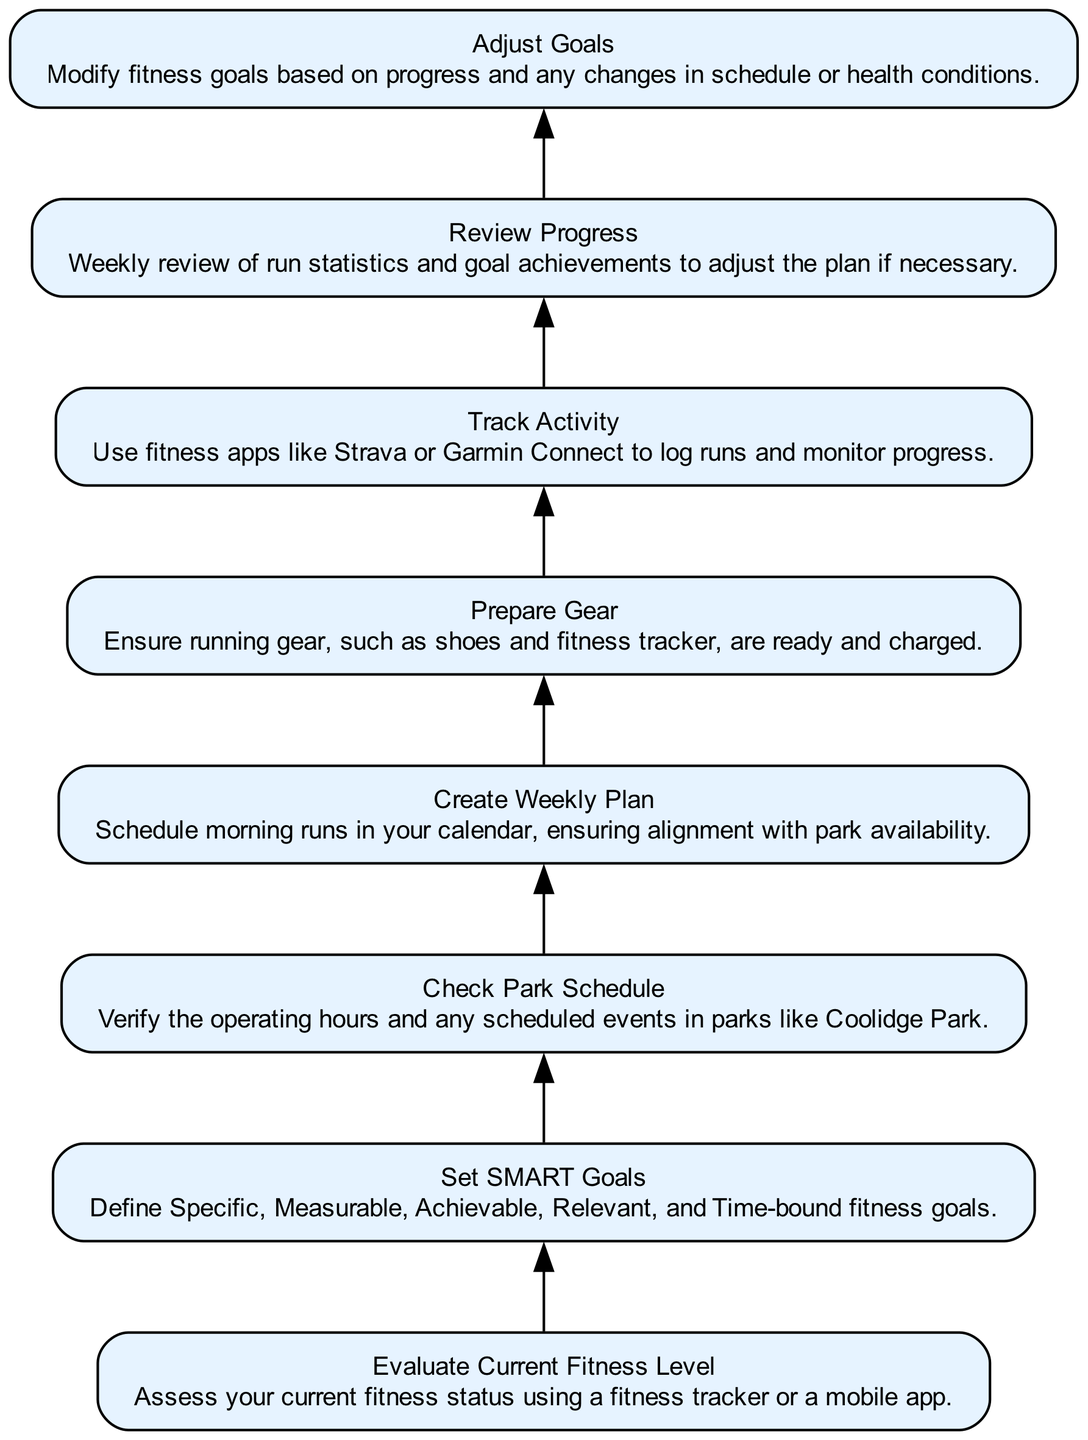What is the first step in the flow chart? The first step in the flow chart is to evaluate current fitness level, which is indicated at the bottom of the chart as step 1.
Answer: Evaluate Current Fitness Level How many steps are there in total? To find the total number of steps, count the nodes displayed in the diagram, which are eight in total.
Answer: 8 What should you do after setting SMART goals? After setting SMART goals, the next step in the flow chart is to check the park schedule, as indicated by the flow direction from step 2 to step 3.
Answer: Check Park Schedule Which step involves assessing fitness status? Assessing your current fitness status is the purpose of the first step in the chart, which corresponds to the label “Evaluate Current Fitness Level.”
Answer: Evaluate Current Fitness Level What is the last step of the process? The last step in the flow chart is to adjust goals, as shown at the top of the diagram as step 8.
Answer: Adjust Goals Which steps involve planning? The steps that involve planning are creating a weekly plan and reviewing progress, corresponding to steps 4 and 7.
Answer: Create Weekly Plan and Review Progress What action follows tracking activity? After tracking activity, the next step is to review progress, where you evaluate your run statistics and goal achievements.
Answer: Review Progress What is the relationship between setting SMART Goals and preparing gear? Setting SMART Goals is the second step, and it leads up to preparing gear, which is the fifth step; there's no direct link but they're sequentially connected through other steps in between.
Answer: Sequential steps What do you do before checking the park schedule? Before checking the park schedule, you need to assess your current fitness level, which is the first step in the flow chart.
Answer: Evaluate Current Fitness Level 